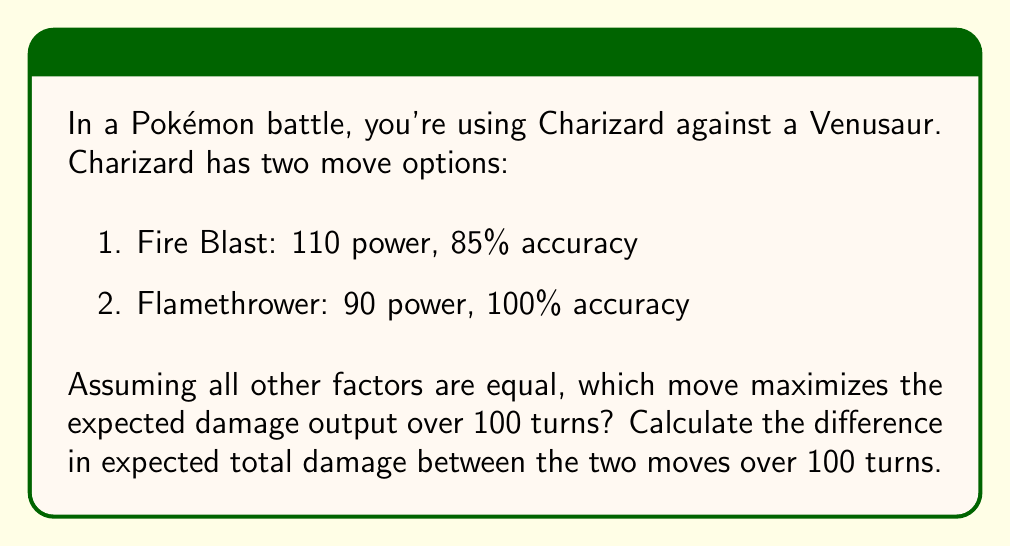Give your solution to this math problem. Let's approach this step-by-step:

1) First, we need to calculate the expected damage per turn for each move.

For Fire Blast:
$$ E(\text{Fire Blast}) = 110 \times 0.85 = 93.5 $$

For Flamethrower:
$$ E(\text{Flamethrower}) = 90 \times 1.00 = 90 $$

2) Now, let's calculate the expected total damage over 100 turns for each move:

Fire Blast:
$$ E(\text{Fire Blast}_{\text{100 turns}}) = 93.5 \times 100 = 9350 $$

Flamethrower:
$$ E(\text{Flamethrower}_{\text{100 turns}}) = 90 \times 100 = 9000 $$

3) To find the difference, we subtract:

$$ \text{Difference} = E(\text{Fire Blast}_{\text{100 turns}}) - E(\text{Flamethrower}_{\text{100 turns}}) $$
$$ = 9350 - 9000 = 350 $$

This means that over 100 turns, Fire Blast is expected to deal 350 more damage than Flamethrower.

4) To determine which move maximizes expected damage output, we compare the expected damage per turn:

Since 93.5 (Fire Blast) > 90 (Flamethrower), Fire Blast maximizes the expected damage output.
Answer: Fire Blast maximizes the expected damage output. The difference in expected total damage between Fire Blast and Flamethrower over 100 turns is 350. 